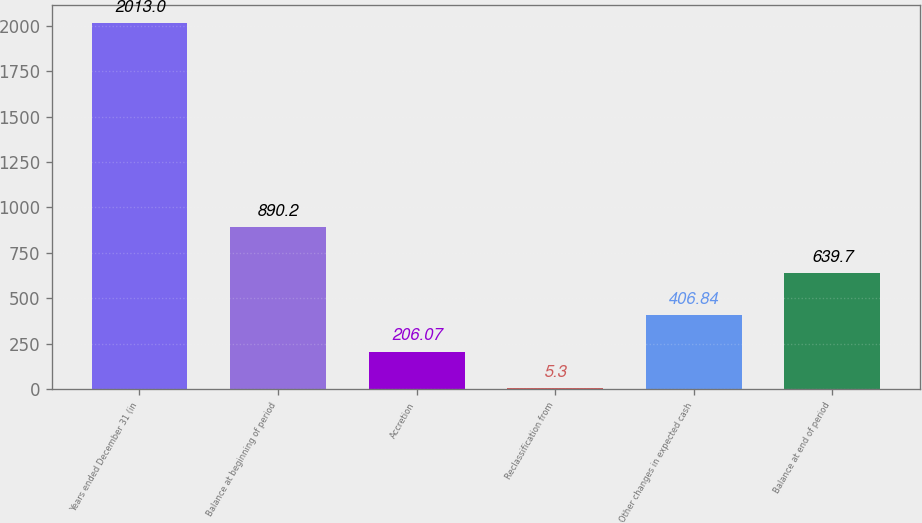Convert chart to OTSL. <chart><loc_0><loc_0><loc_500><loc_500><bar_chart><fcel>Years ended December 31 (in<fcel>Balance at beginning of period<fcel>Accretion<fcel>Reclassification from<fcel>Other changes in expected cash<fcel>Balance at end of period<nl><fcel>2013<fcel>890.2<fcel>206.07<fcel>5.3<fcel>406.84<fcel>639.7<nl></chart> 